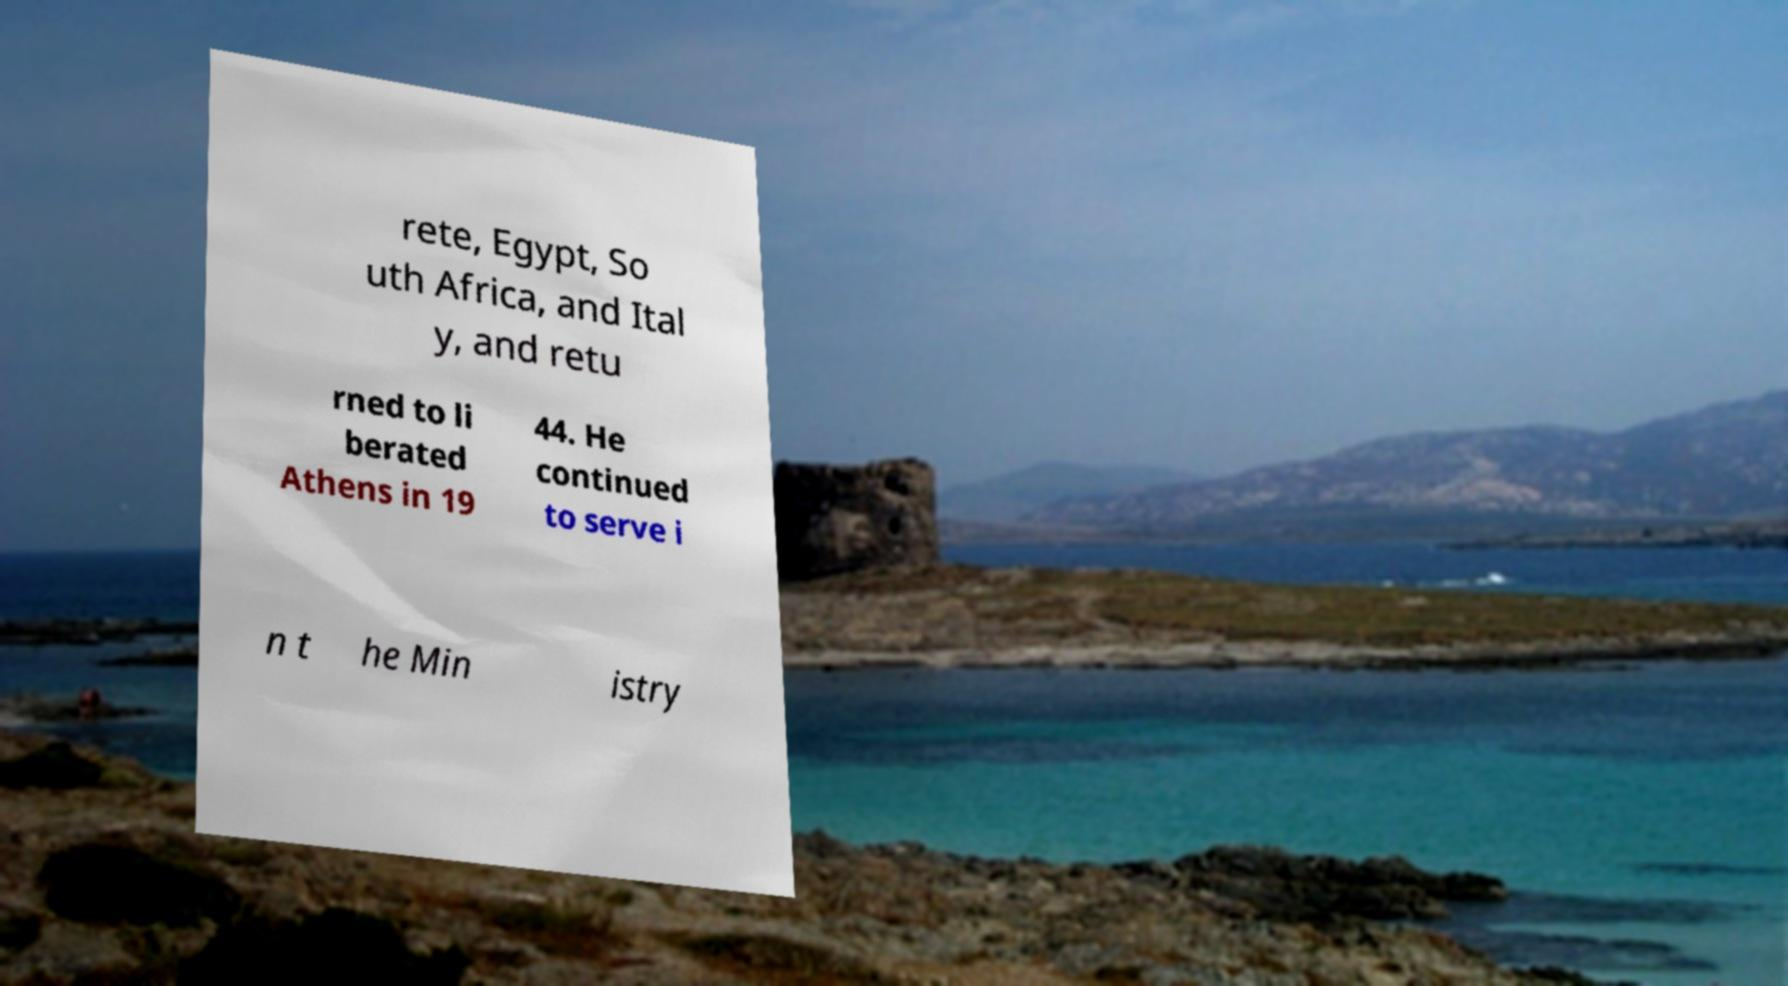For documentation purposes, I need the text within this image transcribed. Could you provide that? rete, Egypt, So uth Africa, and Ital y, and retu rned to li berated Athens in 19 44. He continued to serve i n t he Min istry 